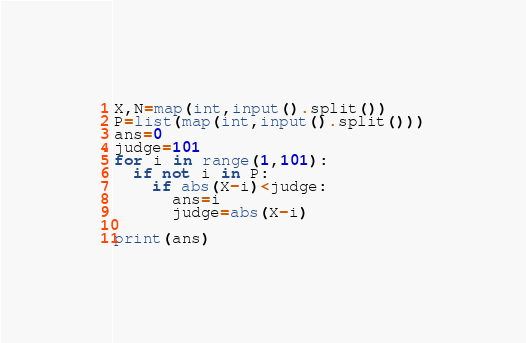<code> <loc_0><loc_0><loc_500><loc_500><_Python_>X,N=map(int,input().split())
P=list(map(int,input().split()))
ans=0
judge=101
for i in range(1,101):
  if not i in P:
    if abs(X-i)<judge:
      ans=i
      judge=abs(X-i)

print(ans)    </code> 